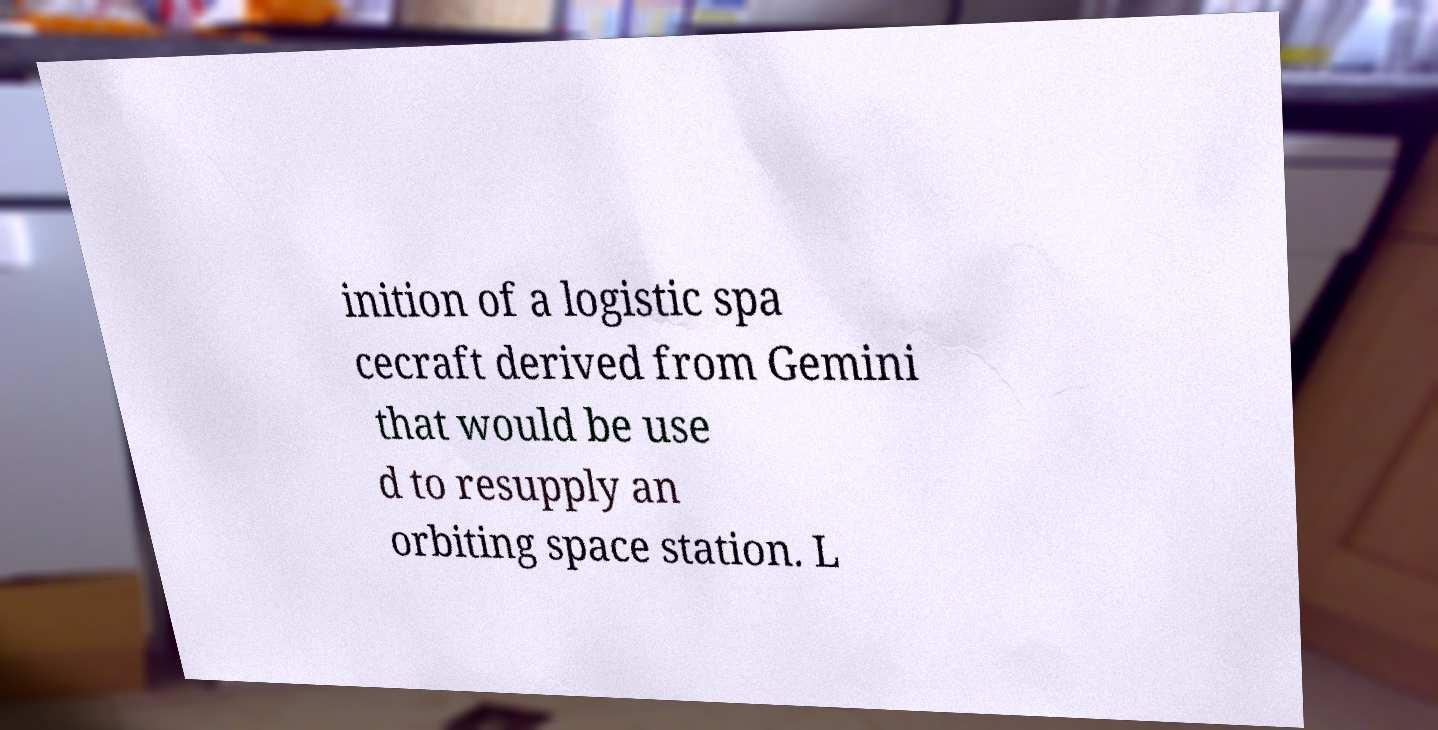Could you extract and type out the text from this image? inition of a logistic spa cecraft derived from Gemini that would be use d to resupply an orbiting space station. L 